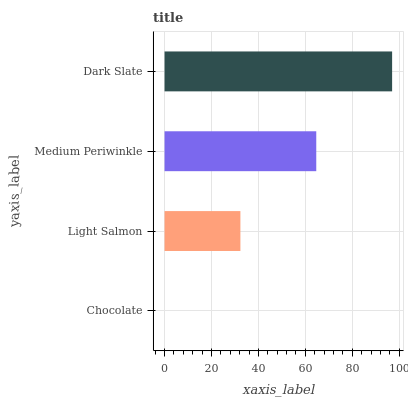Is Chocolate the minimum?
Answer yes or no. Yes. Is Dark Slate the maximum?
Answer yes or no. Yes. Is Light Salmon the minimum?
Answer yes or no. No. Is Light Salmon the maximum?
Answer yes or no. No. Is Light Salmon greater than Chocolate?
Answer yes or no. Yes. Is Chocolate less than Light Salmon?
Answer yes or no. Yes. Is Chocolate greater than Light Salmon?
Answer yes or no. No. Is Light Salmon less than Chocolate?
Answer yes or no. No. Is Medium Periwinkle the high median?
Answer yes or no. Yes. Is Light Salmon the low median?
Answer yes or no. Yes. Is Light Salmon the high median?
Answer yes or no. No. Is Dark Slate the low median?
Answer yes or no. No. 